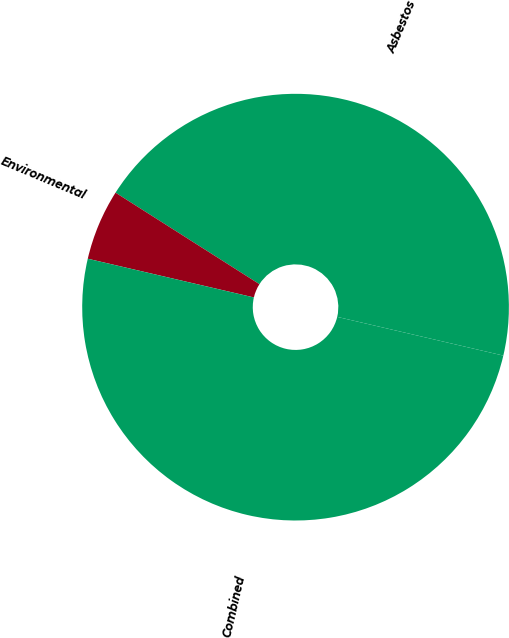Convert chart. <chart><loc_0><loc_0><loc_500><loc_500><pie_chart><fcel>Asbestos<fcel>Environmental<fcel>Combined<nl><fcel>44.63%<fcel>5.37%<fcel>50.0%<nl></chart> 